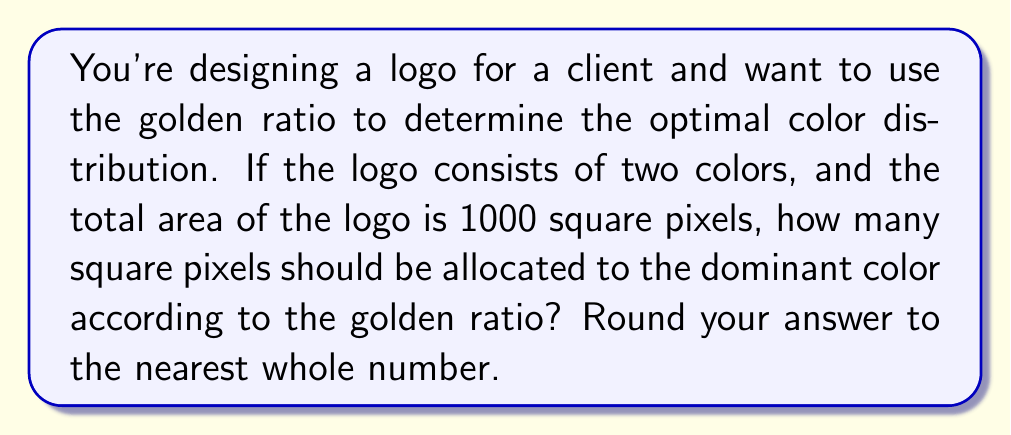Can you solve this math problem? To solve this problem, we need to understand and apply the golden ratio concept:

1. The golden ratio, denoted by φ (phi), is approximately equal to 1.618033988749895.

2. In a design following the golden ratio, the ratio of the larger part to the smaller part is equal to the ratio of the whole to the larger part.

3. Let's denote the area of the dominant color as $x$ and the area of the secondary color as $y$. We know that $x + y = 1000$ (total area).

4. According to the golden ratio principle:

   $$\frac{x}{y} = \frac{x+y}{x} = φ$$

5. Substituting the known values:

   $$\frac{x}{1000-x} = φ$$

6. Cross-multiplying:

   $$x = 1000φ - xφ$$

7. Solving for $x$:

   $$x + xφ = 1000φ$$
   $$x(1 + φ) = 1000φ$$
   $$x = \frac{1000φ}{1 + φ}$$

8. Substituting the value of φ:

   $$x = \frac{1000 * 1.618033988749895}{1 + 1.618033988749895} = 618.0339887498948$$

9. Rounding to the nearest whole number:

   $x ≈ 618$ square pixels

Therefore, the dominant color should occupy approximately 618 square pixels of the logo's total 1000 square pixel area to adhere to the golden ratio principle.
Answer: 618 square pixels 